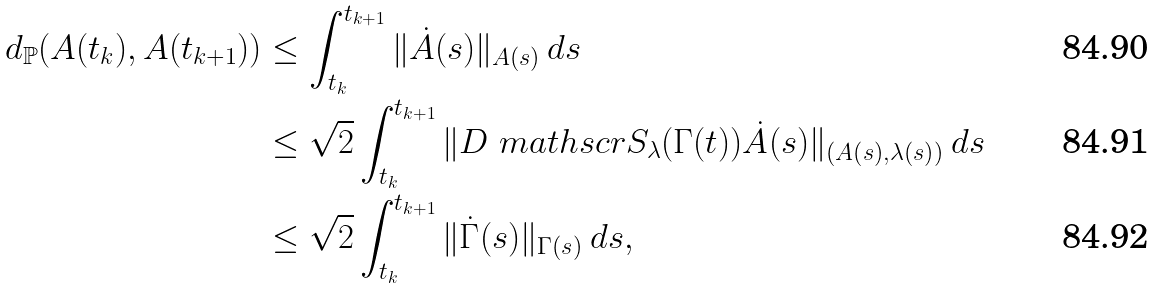Convert formula to latex. <formula><loc_0><loc_0><loc_500><loc_500>d _ { \mathbb { P } } ( A ( t _ { k } ) , A ( t _ { k + 1 } ) ) & \leq \int _ { t _ { k } } ^ { t _ { k + 1 } } \| \dot { A } ( s ) \| _ { A ( s ) } \, d s \\ & \leq \sqrt { 2 } \int _ { t _ { k } } ^ { t _ { k + 1 } } \| D \ m a t h s c r { S } _ { \lambda } ( \Gamma ( t ) ) \dot { A } ( s ) \| _ { ( A ( s ) , \lambda ( s ) ) } \, d s \\ & \leq \sqrt { 2 } \int _ { t _ { k } } ^ { t _ { k + 1 } } \| \dot { \Gamma } ( s ) \| _ { \Gamma ( s ) } \, d s ,</formula> 